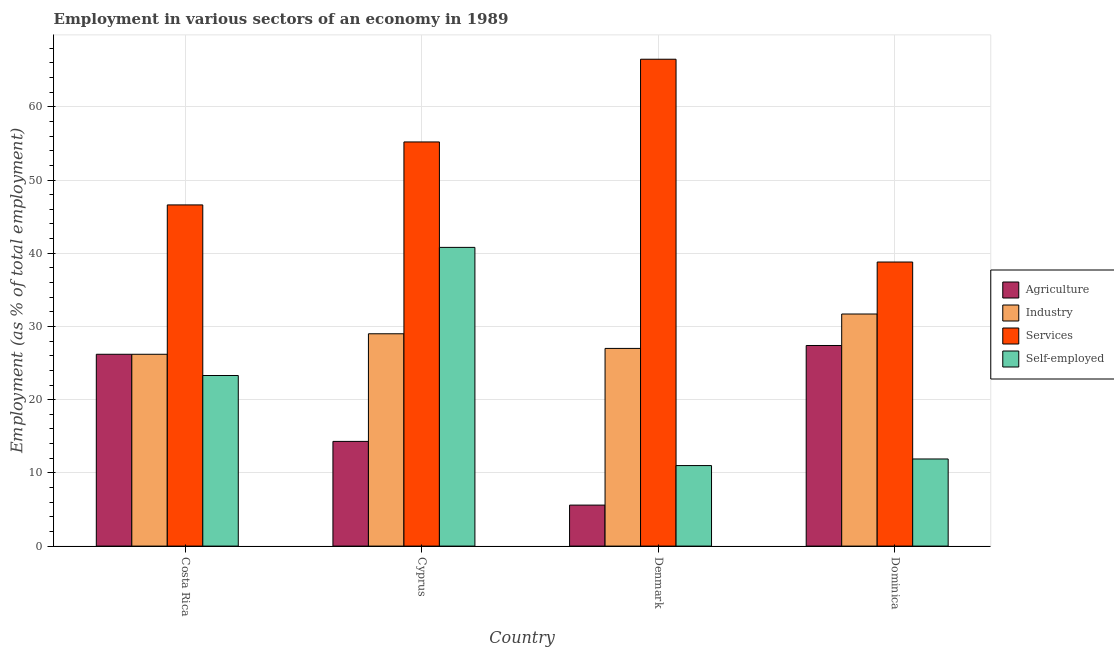How many different coloured bars are there?
Your answer should be very brief. 4. How many groups of bars are there?
Provide a short and direct response. 4. In how many cases, is the number of bars for a given country not equal to the number of legend labels?
Provide a succinct answer. 0. What is the percentage of self employed workers in Cyprus?
Give a very brief answer. 40.8. Across all countries, what is the maximum percentage of self employed workers?
Make the answer very short. 40.8. Across all countries, what is the minimum percentage of workers in agriculture?
Give a very brief answer. 5.6. In which country was the percentage of self employed workers maximum?
Offer a very short reply. Cyprus. In which country was the percentage of workers in industry minimum?
Your answer should be compact. Costa Rica. What is the total percentage of self employed workers in the graph?
Make the answer very short. 87. What is the difference between the percentage of workers in industry in Costa Rica and that in Cyprus?
Offer a terse response. -2.8. What is the difference between the percentage of workers in industry in Cyprus and the percentage of self employed workers in Dominica?
Offer a terse response. 17.1. What is the average percentage of workers in agriculture per country?
Make the answer very short. 18.38. What is the difference between the percentage of workers in industry and percentage of workers in agriculture in Denmark?
Ensure brevity in your answer.  21.4. What is the ratio of the percentage of workers in agriculture in Costa Rica to that in Denmark?
Your response must be concise. 4.68. Is the percentage of self employed workers in Cyprus less than that in Dominica?
Offer a terse response. No. What is the difference between the highest and the second highest percentage of workers in agriculture?
Keep it short and to the point. 1.2. What is the difference between the highest and the lowest percentage of workers in services?
Keep it short and to the point. 27.7. What does the 3rd bar from the left in Dominica represents?
Provide a short and direct response. Services. What does the 1st bar from the right in Cyprus represents?
Make the answer very short. Self-employed. How many bars are there?
Your answer should be compact. 16. Are all the bars in the graph horizontal?
Offer a very short reply. No. How many countries are there in the graph?
Ensure brevity in your answer.  4. What is the difference between two consecutive major ticks on the Y-axis?
Keep it short and to the point. 10. Does the graph contain grids?
Your response must be concise. Yes. How many legend labels are there?
Your answer should be very brief. 4. What is the title of the graph?
Provide a succinct answer. Employment in various sectors of an economy in 1989. What is the label or title of the Y-axis?
Provide a succinct answer. Employment (as % of total employment). What is the Employment (as % of total employment) in Agriculture in Costa Rica?
Ensure brevity in your answer.  26.2. What is the Employment (as % of total employment) of Industry in Costa Rica?
Give a very brief answer. 26.2. What is the Employment (as % of total employment) of Services in Costa Rica?
Give a very brief answer. 46.6. What is the Employment (as % of total employment) of Self-employed in Costa Rica?
Make the answer very short. 23.3. What is the Employment (as % of total employment) of Agriculture in Cyprus?
Offer a terse response. 14.3. What is the Employment (as % of total employment) in Services in Cyprus?
Offer a terse response. 55.2. What is the Employment (as % of total employment) of Self-employed in Cyprus?
Offer a terse response. 40.8. What is the Employment (as % of total employment) of Agriculture in Denmark?
Provide a short and direct response. 5.6. What is the Employment (as % of total employment) of Services in Denmark?
Your answer should be very brief. 66.5. What is the Employment (as % of total employment) of Self-employed in Denmark?
Your answer should be compact. 11. What is the Employment (as % of total employment) in Agriculture in Dominica?
Ensure brevity in your answer.  27.4. What is the Employment (as % of total employment) of Industry in Dominica?
Ensure brevity in your answer.  31.7. What is the Employment (as % of total employment) of Services in Dominica?
Keep it short and to the point. 38.8. What is the Employment (as % of total employment) in Self-employed in Dominica?
Offer a terse response. 11.9. Across all countries, what is the maximum Employment (as % of total employment) of Agriculture?
Ensure brevity in your answer.  27.4. Across all countries, what is the maximum Employment (as % of total employment) in Industry?
Ensure brevity in your answer.  31.7. Across all countries, what is the maximum Employment (as % of total employment) in Services?
Provide a short and direct response. 66.5. Across all countries, what is the maximum Employment (as % of total employment) in Self-employed?
Keep it short and to the point. 40.8. Across all countries, what is the minimum Employment (as % of total employment) of Agriculture?
Provide a succinct answer. 5.6. Across all countries, what is the minimum Employment (as % of total employment) in Industry?
Keep it short and to the point. 26.2. Across all countries, what is the minimum Employment (as % of total employment) in Services?
Provide a succinct answer. 38.8. What is the total Employment (as % of total employment) of Agriculture in the graph?
Your answer should be compact. 73.5. What is the total Employment (as % of total employment) in Industry in the graph?
Offer a terse response. 113.9. What is the total Employment (as % of total employment) in Services in the graph?
Keep it short and to the point. 207.1. What is the total Employment (as % of total employment) in Self-employed in the graph?
Offer a terse response. 87. What is the difference between the Employment (as % of total employment) of Agriculture in Costa Rica and that in Cyprus?
Give a very brief answer. 11.9. What is the difference between the Employment (as % of total employment) of Industry in Costa Rica and that in Cyprus?
Keep it short and to the point. -2.8. What is the difference between the Employment (as % of total employment) in Services in Costa Rica and that in Cyprus?
Your answer should be very brief. -8.6. What is the difference between the Employment (as % of total employment) in Self-employed in Costa Rica and that in Cyprus?
Offer a terse response. -17.5. What is the difference between the Employment (as % of total employment) of Agriculture in Costa Rica and that in Denmark?
Your response must be concise. 20.6. What is the difference between the Employment (as % of total employment) in Industry in Costa Rica and that in Denmark?
Keep it short and to the point. -0.8. What is the difference between the Employment (as % of total employment) in Services in Costa Rica and that in Denmark?
Your answer should be compact. -19.9. What is the difference between the Employment (as % of total employment) of Self-employed in Costa Rica and that in Denmark?
Ensure brevity in your answer.  12.3. What is the difference between the Employment (as % of total employment) in Agriculture in Costa Rica and that in Dominica?
Offer a terse response. -1.2. What is the difference between the Employment (as % of total employment) of Services in Costa Rica and that in Dominica?
Your answer should be compact. 7.8. What is the difference between the Employment (as % of total employment) in Self-employed in Costa Rica and that in Dominica?
Your answer should be compact. 11.4. What is the difference between the Employment (as % of total employment) of Industry in Cyprus and that in Denmark?
Ensure brevity in your answer.  2. What is the difference between the Employment (as % of total employment) of Services in Cyprus and that in Denmark?
Your response must be concise. -11.3. What is the difference between the Employment (as % of total employment) of Self-employed in Cyprus and that in Denmark?
Your answer should be compact. 29.8. What is the difference between the Employment (as % of total employment) of Agriculture in Cyprus and that in Dominica?
Give a very brief answer. -13.1. What is the difference between the Employment (as % of total employment) in Self-employed in Cyprus and that in Dominica?
Your answer should be compact. 28.9. What is the difference between the Employment (as % of total employment) of Agriculture in Denmark and that in Dominica?
Offer a terse response. -21.8. What is the difference between the Employment (as % of total employment) in Services in Denmark and that in Dominica?
Your answer should be compact. 27.7. What is the difference between the Employment (as % of total employment) in Agriculture in Costa Rica and the Employment (as % of total employment) in Self-employed in Cyprus?
Your response must be concise. -14.6. What is the difference between the Employment (as % of total employment) in Industry in Costa Rica and the Employment (as % of total employment) in Services in Cyprus?
Keep it short and to the point. -29. What is the difference between the Employment (as % of total employment) of Industry in Costa Rica and the Employment (as % of total employment) of Self-employed in Cyprus?
Give a very brief answer. -14.6. What is the difference between the Employment (as % of total employment) of Agriculture in Costa Rica and the Employment (as % of total employment) of Industry in Denmark?
Your answer should be very brief. -0.8. What is the difference between the Employment (as % of total employment) of Agriculture in Costa Rica and the Employment (as % of total employment) of Services in Denmark?
Your response must be concise. -40.3. What is the difference between the Employment (as % of total employment) in Agriculture in Costa Rica and the Employment (as % of total employment) in Self-employed in Denmark?
Provide a succinct answer. 15.2. What is the difference between the Employment (as % of total employment) of Industry in Costa Rica and the Employment (as % of total employment) of Services in Denmark?
Offer a terse response. -40.3. What is the difference between the Employment (as % of total employment) in Services in Costa Rica and the Employment (as % of total employment) in Self-employed in Denmark?
Provide a succinct answer. 35.6. What is the difference between the Employment (as % of total employment) of Agriculture in Costa Rica and the Employment (as % of total employment) of Services in Dominica?
Provide a short and direct response. -12.6. What is the difference between the Employment (as % of total employment) of Industry in Costa Rica and the Employment (as % of total employment) of Self-employed in Dominica?
Make the answer very short. 14.3. What is the difference between the Employment (as % of total employment) in Services in Costa Rica and the Employment (as % of total employment) in Self-employed in Dominica?
Offer a very short reply. 34.7. What is the difference between the Employment (as % of total employment) in Agriculture in Cyprus and the Employment (as % of total employment) in Services in Denmark?
Offer a very short reply. -52.2. What is the difference between the Employment (as % of total employment) in Industry in Cyprus and the Employment (as % of total employment) in Services in Denmark?
Offer a very short reply. -37.5. What is the difference between the Employment (as % of total employment) of Services in Cyprus and the Employment (as % of total employment) of Self-employed in Denmark?
Your answer should be compact. 44.2. What is the difference between the Employment (as % of total employment) of Agriculture in Cyprus and the Employment (as % of total employment) of Industry in Dominica?
Your answer should be very brief. -17.4. What is the difference between the Employment (as % of total employment) in Agriculture in Cyprus and the Employment (as % of total employment) in Services in Dominica?
Keep it short and to the point. -24.5. What is the difference between the Employment (as % of total employment) of Agriculture in Cyprus and the Employment (as % of total employment) of Self-employed in Dominica?
Provide a short and direct response. 2.4. What is the difference between the Employment (as % of total employment) of Industry in Cyprus and the Employment (as % of total employment) of Services in Dominica?
Provide a short and direct response. -9.8. What is the difference between the Employment (as % of total employment) in Industry in Cyprus and the Employment (as % of total employment) in Self-employed in Dominica?
Offer a very short reply. 17.1. What is the difference between the Employment (as % of total employment) in Services in Cyprus and the Employment (as % of total employment) in Self-employed in Dominica?
Your answer should be compact. 43.3. What is the difference between the Employment (as % of total employment) in Agriculture in Denmark and the Employment (as % of total employment) in Industry in Dominica?
Provide a short and direct response. -26.1. What is the difference between the Employment (as % of total employment) of Agriculture in Denmark and the Employment (as % of total employment) of Services in Dominica?
Offer a very short reply. -33.2. What is the difference between the Employment (as % of total employment) in Industry in Denmark and the Employment (as % of total employment) in Services in Dominica?
Give a very brief answer. -11.8. What is the difference between the Employment (as % of total employment) in Services in Denmark and the Employment (as % of total employment) in Self-employed in Dominica?
Your response must be concise. 54.6. What is the average Employment (as % of total employment) in Agriculture per country?
Keep it short and to the point. 18.38. What is the average Employment (as % of total employment) of Industry per country?
Give a very brief answer. 28.48. What is the average Employment (as % of total employment) in Services per country?
Offer a terse response. 51.77. What is the average Employment (as % of total employment) in Self-employed per country?
Provide a short and direct response. 21.75. What is the difference between the Employment (as % of total employment) in Agriculture and Employment (as % of total employment) in Services in Costa Rica?
Ensure brevity in your answer.  -20.4. What is the difference between the Employment (as % of total employment) in Industry and Employment (as % of total employment) in Services in Costa Rica?
Offer a very short reply. -20.4. What is the difference between the Employment (as % of total employment) of Industry and Employment (as % of total employment) of Self-employed in Costa Rica?
Make the answer very short. 2.9. What is the difference between the Employment (as % of total employment) in Services and Employment (as % of total employment) in Self-employed in Costa Rica?
Provide a succinct answer. 23.3. What is the difference between the Employment (as % of total employment) of Agriculture and Employment (as % of total employment) of Industry in Cyprus?
Your answer should be very brief. -14.7. What is the difference between the Employment (as % of total employment) in Agriculture and Employment (as % of total employment) in Services in Cyprus?
Keep it short and to the point. -40.9. What is the difference between the Employment (as % of total employment) of Agriculture and Employment (as % of total employment) of Self-employed in Cyprus?
Offer a very short reply. -26.5. What is the difference between the Employment (as % of total employment) in Industry and Employment (as % of total employment) in Services in Cyprus?
Offer a very short reply. -26.2. What is the difference between the Employment (as % of total employment) of Services and Employment (as % of total employment) of Self-employed in Cyprus?
Keep it short and to the point. 14.4. What is the difference between the Employment (as % of total employment) of Agriculture and Employment (as % of total employment) of Industry in Denmark?
Provide a succinct answer. -21.4. What is the difference between the Employment (as % of total employment) of Agriculture and Employment (as % of total employment) of Services in Denmark?
Offer a very short reply. -60.9. What is the difference between the Employment (as % of total employment) in Industry and Employment (as % of total employment) in Services in Denmark?
Offer a very short reply. -39.5. What is the difference between the Employment (as % of total employment) of Industry and Employment (as % of total employment) of Self-employed in Denmark?
Keep it short and to the point. 16. What is the difference between the Employment (as % of total employment) of Services and Employment (as % of total employment) of Self-employed in Denmark?
Provide a succinct answer. 55.5. What is the difference between the Employment (as % of total employment) in Agriculture and Employment (as % of total employment) in Services in Dominica?
Give a very brief answer. -11.4. What is the difference between the Employment (as % of total employment) of Industry and Employment (as % of total employment) of Self-employed in Dominica?
Offer a very short reply. 19.8. What is the difference between the Employment (as % of total employment) in Services and Employment (as % of total employment) in Self-employed in Dominica?
Your response must be concise. 26.9. What is the ratio of the Employment (as % of total employment) of Agriculture in Costa Rica to that in Cyprus?
Offer a terse response. 1.83. What is the ratio of the Employment (as % of total employment) of Industry in Costa Rica to that in Cyprus?
Offer a terse response. 0.9. What is the ratio of the Employment (as % of total employment) in Services in Costa Rica to that in Cyprus?
Offer a terse response. 0.84. What is the ratio of the Employment (as % of total employment) in Self-employed in Costa Rica to that in Cyprus?
Your response must be concise. 0.57. What is the ratio of the Employment (as % of total employment) of Agriculture in Costa Rica to that in Denmark?
Offer a very short reply. 4.68. What is the ratio of the Employment (as % of total employment) of Industry in Costa Rica to that in Denmark?
Provide a short and direct response. 0.97. What is the ratio of the Employment (as % of total employment) in Services in Costa Rica to that in Denmark?
Keep it short and to the point. 0.7. What is the ratio of the Employment (as % of total employment) in Self-employed in Costa Rica to that in Denmark?
Provide a short and direct response. 2.12. What is the ratio of the Employment (as % of total employment) in Agriculture in Costa Rica to that in Dominica?
Offer a very short reply. 0.96. What is the ratio of the Employment (as % of total employment) of Industry in Costa Rica to that in Dominica?
Provide a short and direct response. 0.83. What is the ratio of the Employment (as % of total employment) of Services in Costa Rica to that in Dominica?
Your response must be concise. 1.2. What is the ratio of the Employment (as % of total employment) in Self-employed in Costa Rica to that in Dominica?
Make the answer very short. 1.96. What is the ratio of the Employment (as % of total employment) of Agriculture in Cyprus to that in Denmark?
Make the answer very short. 2.55. What is the ratio of the Employment (as % of total employment) of Industry in Cyprus to that in Denmark?
Provide a succinct answer. 1.07. What is the ratio of the Employment (as % of total employment) of Services in Cyprus to that in Denmark?
Your answer should be very brief. 0.83. What is the ratio of the Employment (as % of total employment) of Self-employed in Cyprus to that in Denmark?
Make the answer very short. 3.71. What is the ratio of the Employment (as % of total employment) of Agriculture in Cyprus to that in Dominica?
Give a very brief answer. 0.52. What is the ratio of the Employment (as % of total employment) of Industry in Cyprus to that in Dominica?
Offer a very short reply. 0.91. What is the ratio of the Employment (as % of total employment) of Services in Cyprus to that in Dominica?
Ensure brevity in your answer.  1.42. What is the ratio of the Employment (as % of total employment) of Self-employed in Cyprus to that in Dominica?
Provide a succinct answer. 3.43. What is the ratio of the Employment (as % of total employment) of Agriculture in Denmark to that in Dominica?
Your answer should be compact. 0.2. What is the ratio of the Employment (as % of total employment) in Industry in Denmark to that in Dominica?
Give a very brief answer. 0.85. What is the ratio of the Employment (as % of total employment) of Services in Denmark to that in Dominica?
Ensure brevity in your answer.  1.71. What is the ratio of the Employment (as % of total employment) of Self-employed in Denmark to that in Dominica?
Provide a short and direct response. 0.92. What is the difference between the highest and the second highest Employment (as % of total employment) of Agriculture?
Keep it short and to the point. 1.2. What is the difference between the highest and the second highest Employment (as % of total employment) in Industry?
Your response must be concise. 2.7. What is the difference between the highest and the lowest Employment (as % of total employment) of Agriculture?
Make the answer very short. 21.8. What is the difference between the highest and the lowest Employment (as % of total employment) in Services?
Provide a short and direct response. 27.7. What is the difference between the highest and the lowest Employment (as % of total employment) of Self-employed?
Make the answer very short. 29.8. 